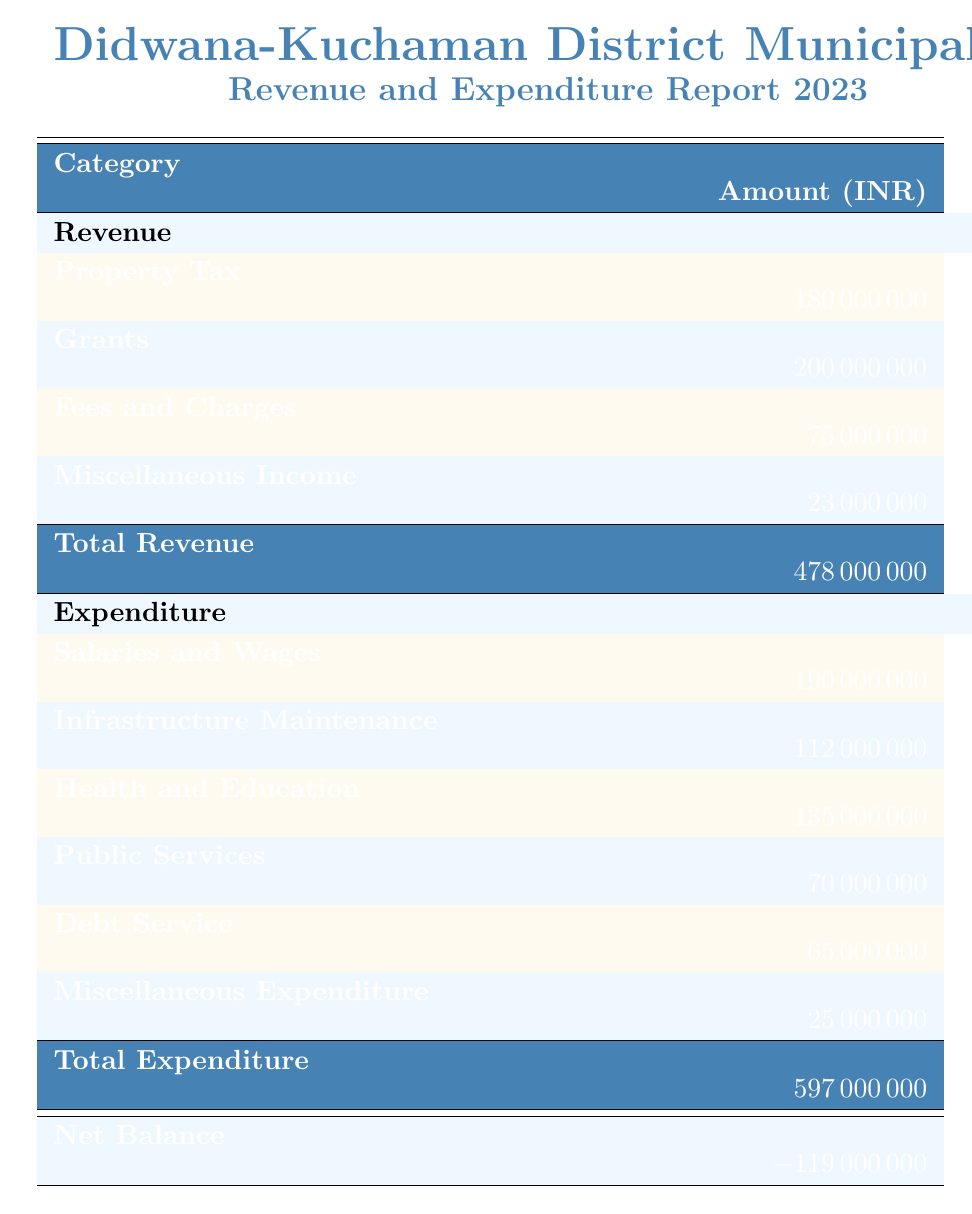What is the total revenue reported for Didwana-Kuchaman District Municipality in 2023? The total revenue is listed in the table under the "Total Revenue" row. According to the table, it sums up to 478000000.
Answer: 478000000 How much revenue does the Didwana-Kuchaman District Municipality earn from property tax? The table indicates property tax revenue as the sum of residential, commercial, industrial, and agricultural. Adding them up gives: 75000000 + 55000000 + 35000000 + 15000000 = 180000000.
Answer: 180000000 Is the expenditure on health and education more than the expenditure on public services? The table lists health and education expenditure as 135000000 and public services as 70000000. Since 135000000 is greater than 70000000, the statement is true.
Answer: Yes What is the net balance for Didwana-Kuchaman District Municipality? The net balance is found at the bottom of the table, which is the total revenue minus total expenditure. The total revenue is 478000000 and the total expenditure is 597000000, yielding a net balance of 478000000 - 597000000 = -119000000.
Answer: -119000000 How much does the municipality spend on salaries and wages compared to infrastructure maintenance? Salaries and wages expenditure is listed as 190000000 and infrastructure maintenance is 112000000. The difference in expenditure shows that salaries and wages are higher by 190000000 - 112000000 = 78000000.
Answer: 78000000 Which category of expenditure has the highest amount? The expenditures can be compared from the table, and salaries and wages at 190000000 are noted as the highest among all categories, which are infrastructure maintenance, health and education, public services, debt service, and miscellaneous expenditure.
Answer: Salaries and wages What is the total expenditure? The total expenditure can be determined by looking at the specified total at the bottom of the expenditure section of the table. The table shows that the total expenditure is 597000000.
Answer: 597000000 Does the Didwana-Kuchaman District Municipality have a surplus or deficit in their financial report? A surplus occurs when total revenue exceeds total expenditure. In this case, total revenue is 478000000 and total expenditure is 597000000, meaning the municipality has a deficit.
Answer: Deficit By how much do grants exceed fees and charges? Grants total 200000000 while fees and charges total 75000000. To find the difference, we subtract: 200000000 - 75000000 = 125000000.
Answer: 125000000 